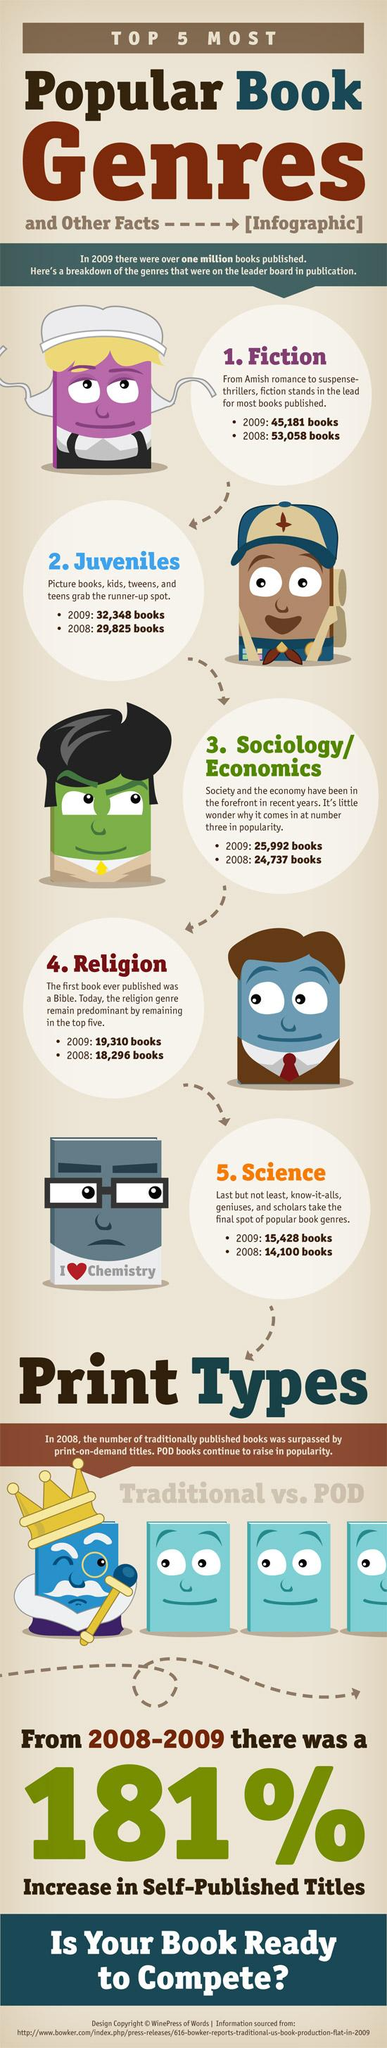Draw attention to some important aspects in this diagram. In 2008, it is estimated that approximately 14,100 science genre books were published. In the year 2009, the genre of books that were least published was science fiction. In the year 2009, the most commonly published genre of books was fiction. According to the data, a total of 53,058 fiction genre books were published in 2008. 